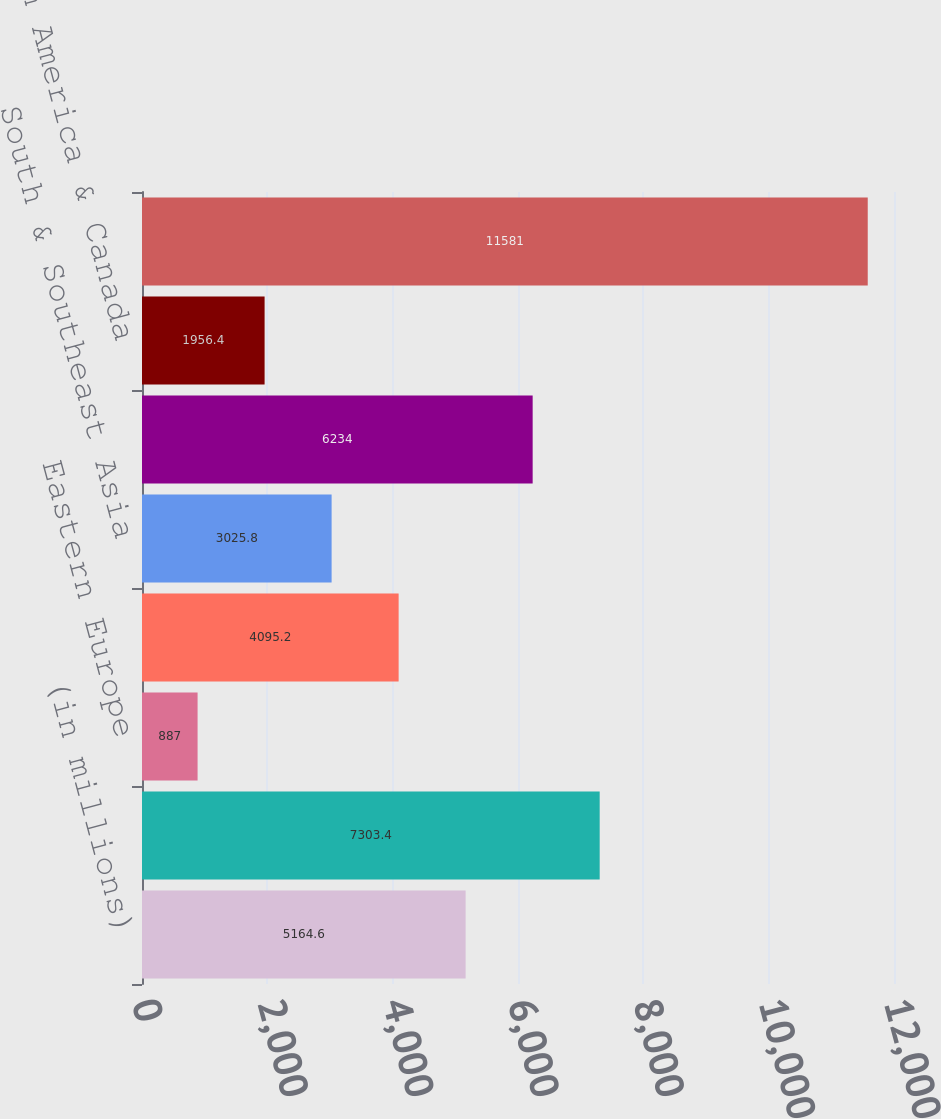Convert chart to OTSL. <chart><loc_0><loc_0><loc_500><loc_500><bar_chart><fcel>(in millions)<fcel>European Union<fcel>Eastern Europe<fcel>Middle East & Africa<fcel>South & Southeast Asia<fcel>East Asia & Australia<fcel>Latin America & Canada<fcel>Operating income<nl><fcel>5164.6<fcel>7303.4<fcel>887<fcel>4095.2<fcel>3025.8<fcel>6234<fcel>1956.4<fcel>11581<nl></chart> 